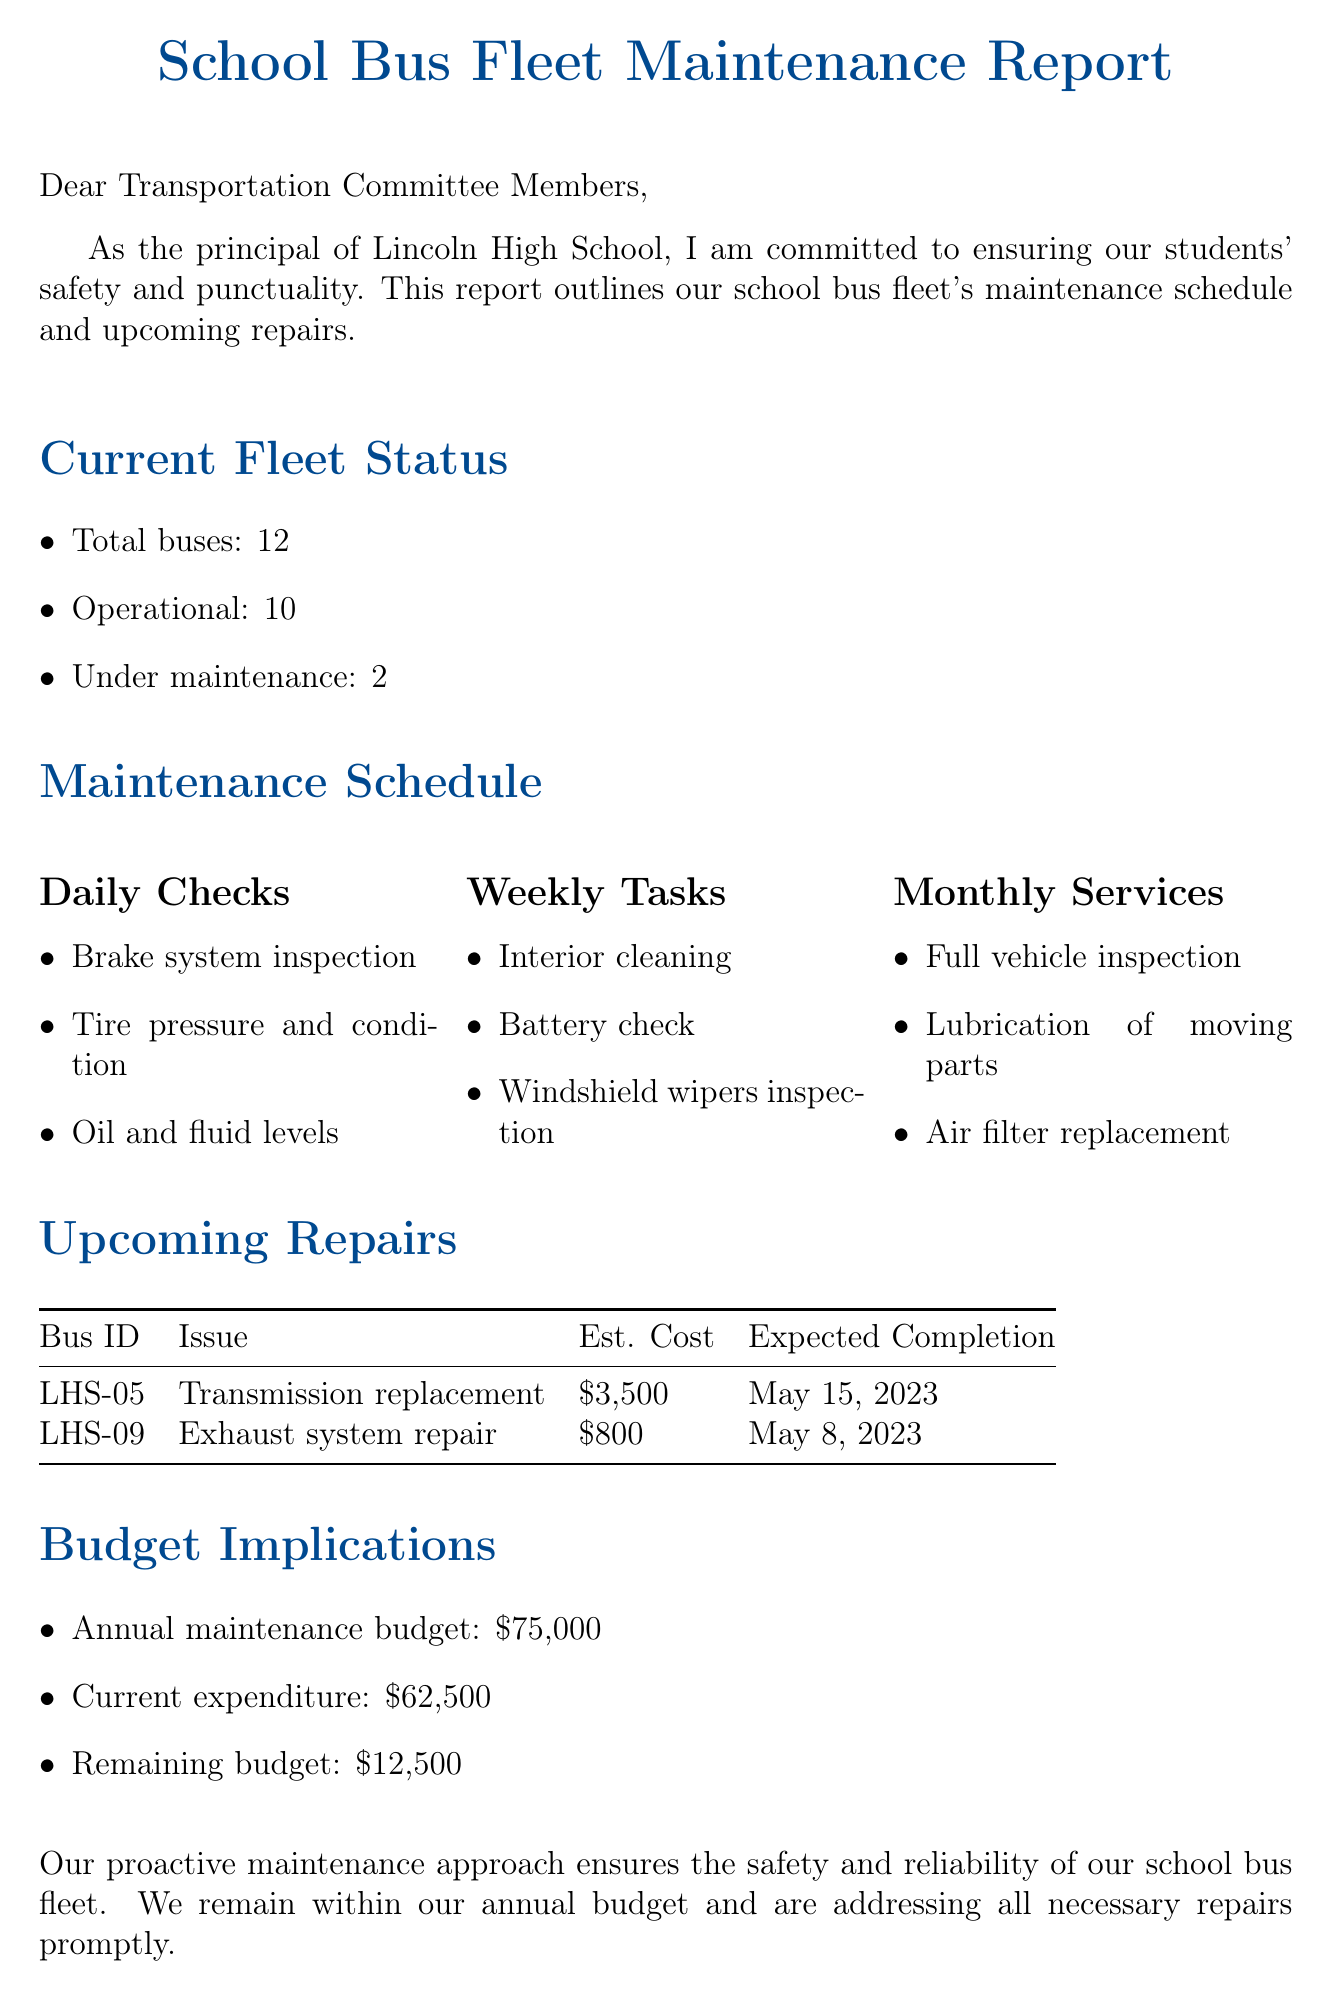What is the total number of buses in the fleet? The total number of buses is explicitly stated in the document as 12.
Answer: 12 How many buses are currently operational? The document specifies that 10 buses are operational.
Answer: 10 What is the estimated cost for the transmission replacement on bus LHS-05? The estimated cost for the transmission replacement is given as $3,500.
Answer: $3,500 When is the expected completion date for the exhaust system repair on bus LHS-09? The expected completion date is listed as May 8, 2023.
Answer: May 8, 2023 What is the current expenditure for bus maintenance? The current expenditure is mentioned as $62,500 in the document.
Answer: $62,500 What type of checks are performed daily on the buses? The document outlines daily checks, including brake system inspection, tire pressure and condition, and oil and fluid levels.
Answer: Brake system inspection, tire pressure and condition, oil and fluid levels How many buses are currently under maintenance? The document states that 2 buses are under maintenance.
Answer: 2 What is the remaining budget for maintenance? The remaining budget is provided as $12,500.
Answer: $12,500 What proactive measure is indicated in the conclusion of the report? The conclusion mentions a proactive maintenance approach to ensure safety and reliability.
Answer: Proactive maintenance approach 